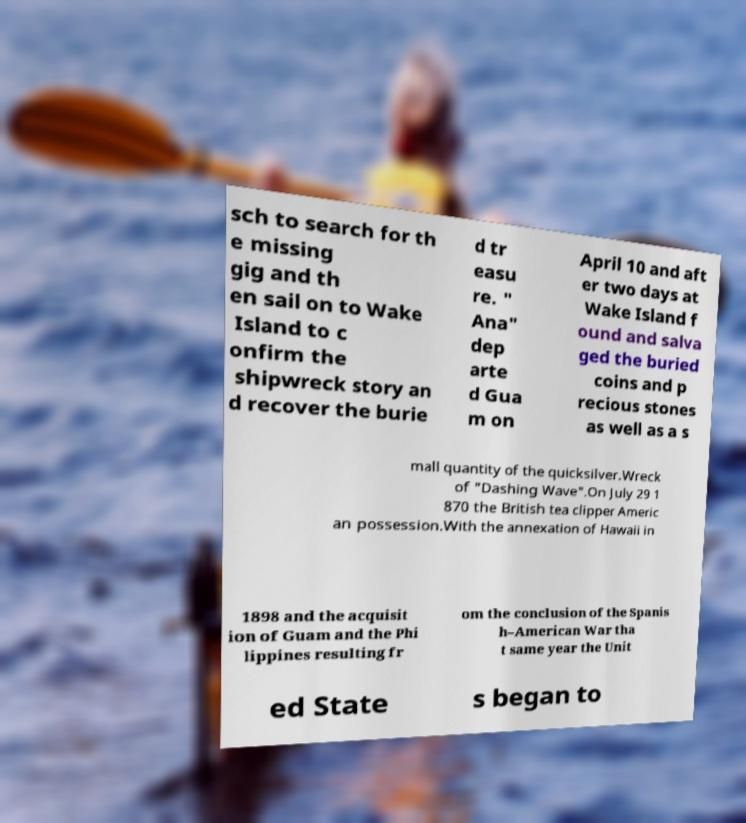Please read and relay the text visible in this image. What does it say? sch to search for th e missing gig and th en sail on to Wake Island to c onfirm the shipwreck story an d recover the burie d tr easu re. " Ana" dep arte d Gua m on April 10 and aft er two days at Wake Island f ound and salva ged the buried coins and p recious stones as well as a s mall quantity of the quicksilver.Wreck of "Dashing Wave".On July 29 1 870 the British tea clipper Americ an possession.With the annexation of Hawaii in 1898 and the acquisit ion of Guam and the Phi lippines resulting fr om the conclusion of the Spanis h–American War tha t same year the Unit ed State s began to 